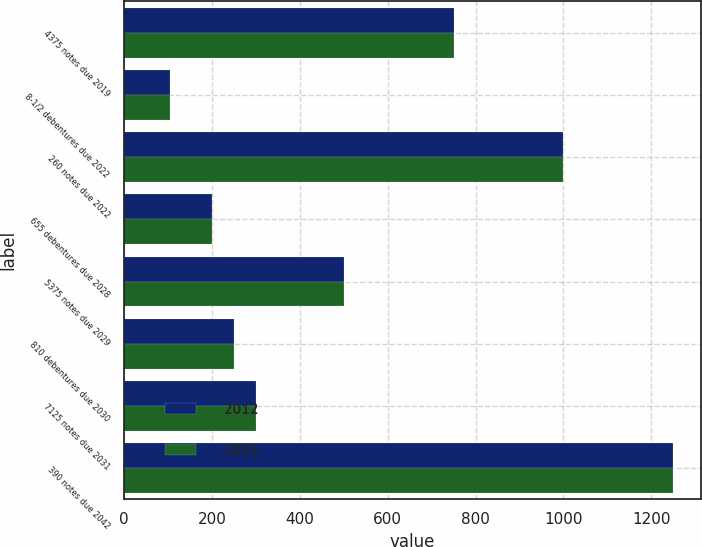Convert chart to OTSL. <chart><loc_0><loc_0><loc_500><loc_500><stacked_bar_chart><ecel><fcel>4375 notes due 2019<fcel>8-1/2 debentures due 2022<fcel>260 notes due 2022<fcel>655 debentures due 2028<fcel>5375 notes due 2029<fcel>810 debentures due 2030<fcel>7125 notes due 2031<fcel>390 notes due 2042<nl><fcel>2012<fcel>750<fcel>105<fcel>1000<fcel>200<fcel>500<fcel>250<fcel>300<fcel>1250<nl><fcel>2013<fcel>750<fcel>105<fcel>1000<fcel>200<fcel>500<fcel>250<fcel>300<fcel>1250<nl></chart> 